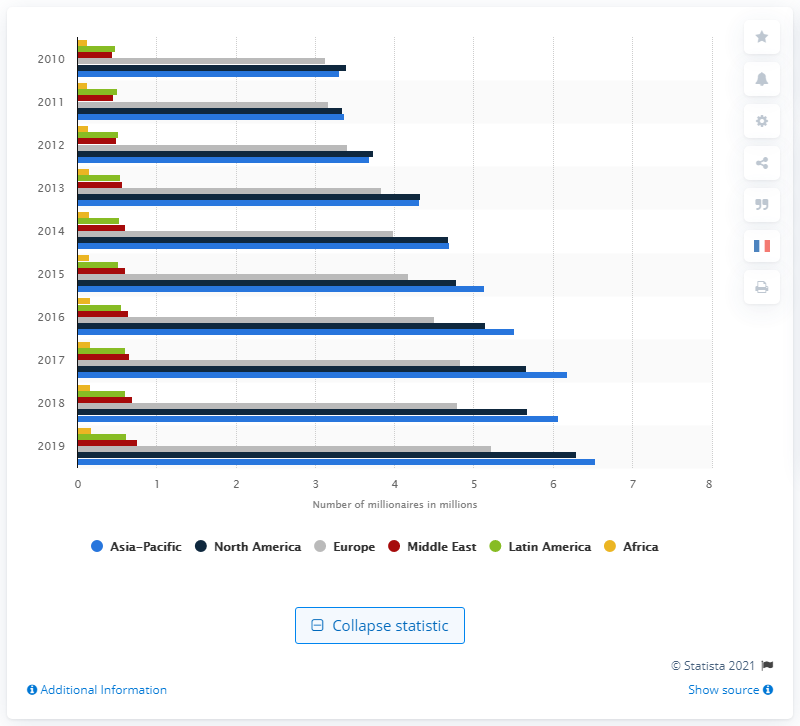How does the growth of millionaires in Asia Pacific compare to other regions over the last decade? Asia Pacific's growth in the number of millionaires outpaces most other regions from 2010 to 2019. For instance, although North America and Europe also saw increases, the growth rate in Asia was more pronounced, reflecting the dynamic economic development and wealth accumulation in that region. 